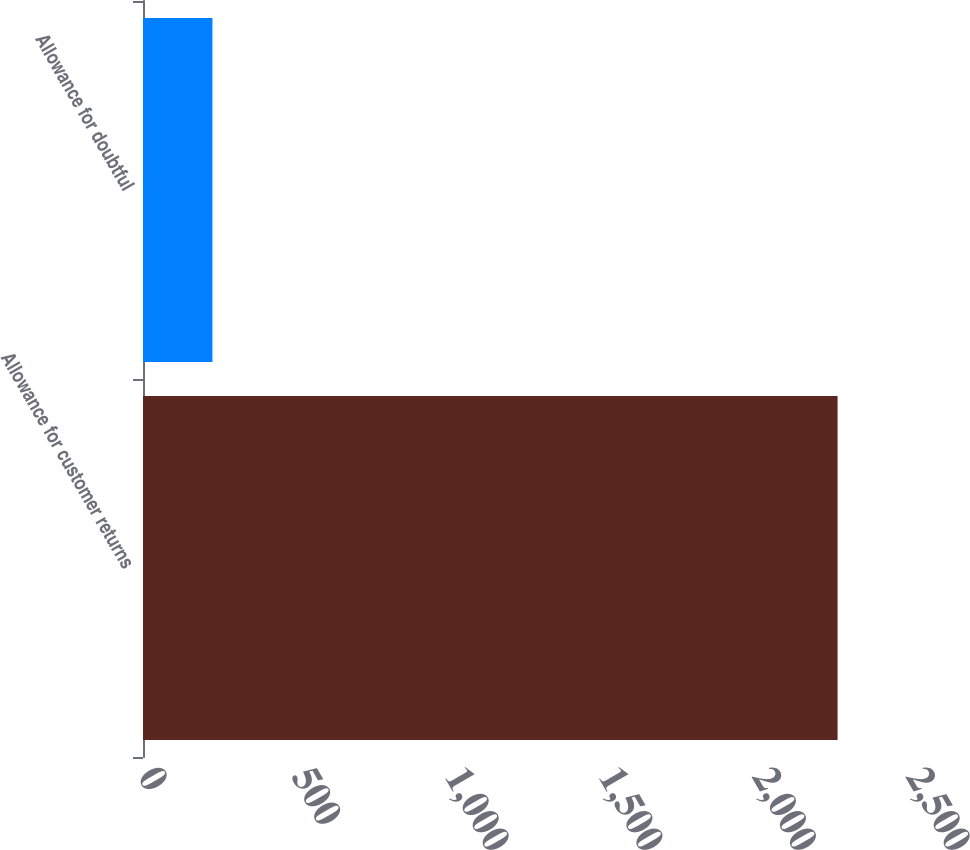Convert chart to OTSL. <chart><loc_0><loc_0><loc_500><loc_500><bar_chart><fcel>Allowance for customer returns<fcel>Allowance for doubtful<nl><fcel>2261<fcel>226<nl></chart> 